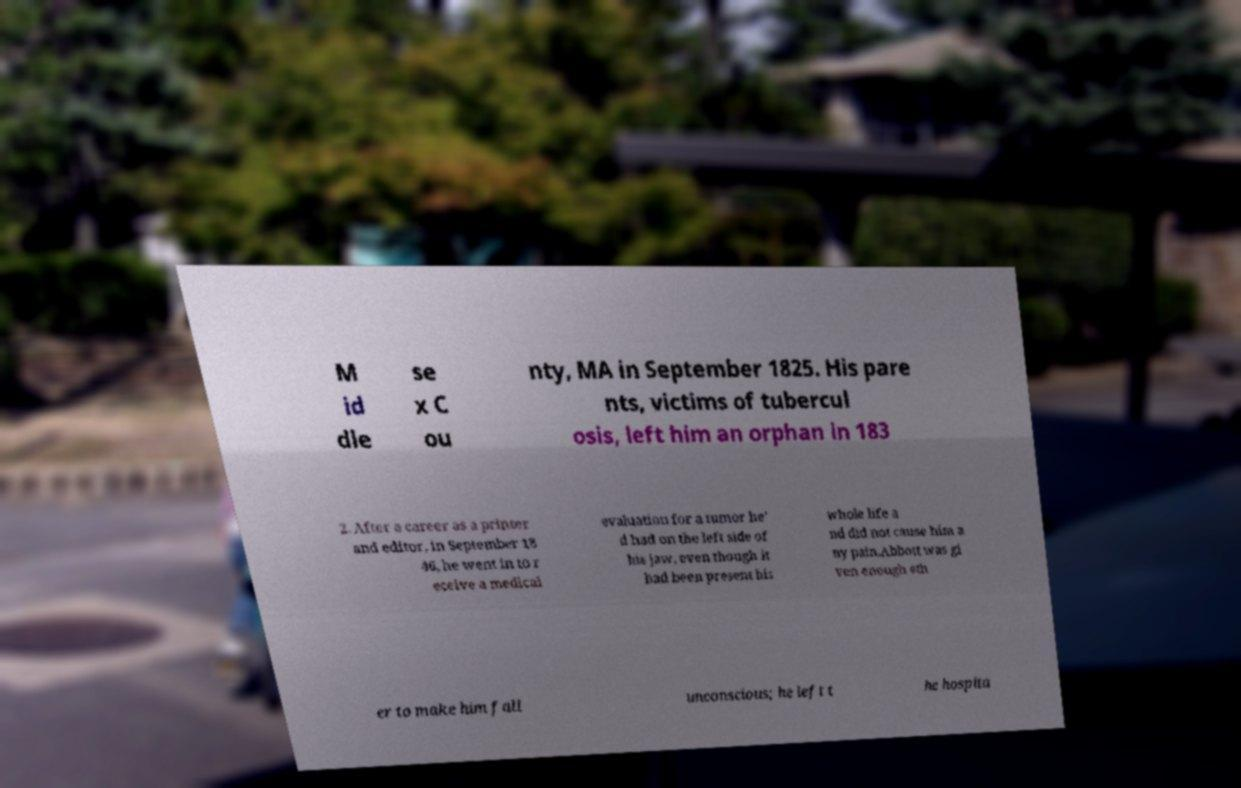For documentation purposes, I need the text within this image transcribed. Could you provide that? M id dle se x C ou nty, MA in September 1825. His pare nts, victims of tubercul osis, left him an orphan in 183 2. After a career as a printer and editor, in September 18 46, he went in to r eceive a medical evaluation for a tumor he' d had on the left side of his jaw, even though it had been present his whole life a nd did not cause him a ny pain.Abbott was gi ven enough eth er to make him fall unconscious; he left t he hospita 